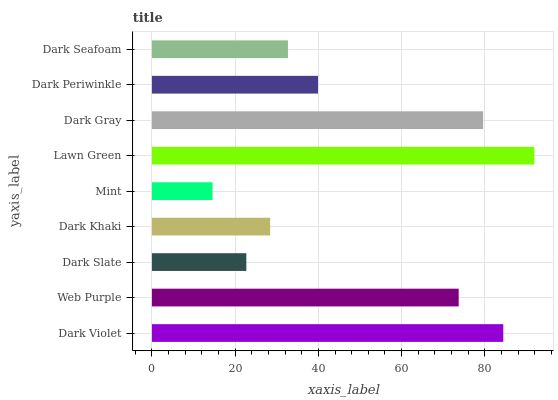Is Mint the minimum?
Answer yes or no. Yes. Is Lawn Green the maximum?
Answer yes or no. Yes. Is Web Purple the minimum?
Answer yes or no. No. Is Web Purple the maximum?
Answer yes or no. No. Is Dark Violet greater than Web Purple?
Answer yes or no. Yes. Is Web Purple less than Dark Violet?
Answer yes or no. Yes. Is Web Purple greater than Dark Violet?
Answer yes or no. No. Is Dark Violet less than Web Purple?
Answer yes or no. No. Is Dark Periwinkle the high median?
Answer yes or no. Yes. Is Dark Periwinkle the low median?
Answer yes or no. Yes. Is Dark Slate the high median?
Answer yes or no. No. Is Dark Khaki the low median?
Answer yes or no. No. 